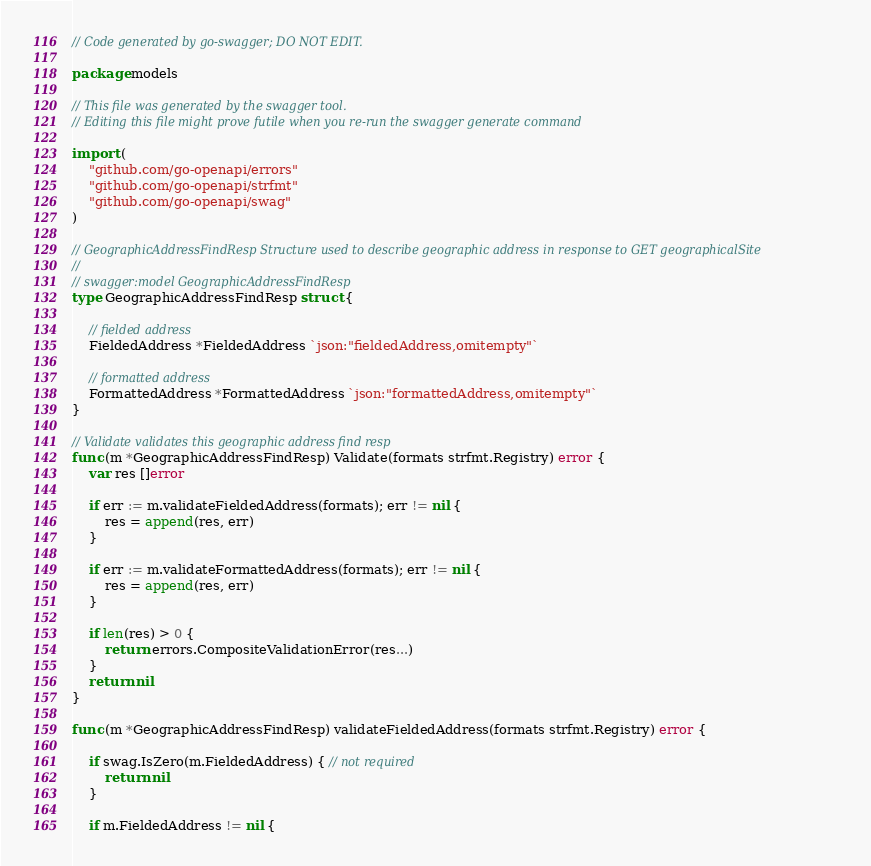Convert code to text. <code><loc_0><loc_0><loc_500><loc_500><_Go_>// Code generated by go-swagger; DO NOT EDIT.

package models

// This file was generated by the swagger tool.
// Editing this file might prove futile when you re-run the swagger generate command

import (
	"github.com/go-openapi/errors"
	"github.com/go-openapi/strfmt"
	"github.com/go-openapi/swag"
)

// GeographicAddressFindResp Structure used to describe geographic address in response to GET geographicalSite
//
// swagger:model GeographicAddressFindResp
type GeographicAddressFindResp struct {

	// fielded address
	FieldedAddress *FieldedAddress `json:"fieldedAddress,omitempty"`

	// formatted address
	FormattedAddress *FormattedAddress `json:"formattedAddress,omitempty"`
}

// Validate validates this geographic address find resp
func (m *GeographicAddressFindResp) Validate(formats strfmt.Registry) error {
	var res []error

	if err := m.validateFieldedAddress(formats); err != nil {
		res = append(res, err)
	}

	if err := m.validateFormattedAddress(formats); err != nil {
		res = append(res, err)
	}

	if len(res) > 0 {
		return errors.CompositeValidationError(res...)
	}
	return nil
}

func (m *GeographicAddressFindResp) validateFieldedAddress(formats strfmt.Registry) error {

	if swag.IsZero(m.FieldedAddress) { // not required
		return nil
	}

	if m.FieldedAddress != nil {</code> 